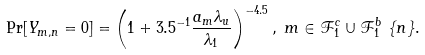<formula> <loc_0><loc_0><loc_500><loc_500>& \Pr [ Y _ { m , n } = 0 ] = \left ( 1 + 3 . 5 ^ { - 1 } \frac { a _ { m } \lambda _ { u } } { \lambda _ { 1 } } \right ) ^ { - 4 . 5 } , \ m \in \mathcal { F } _ { 1 } ^ { c } \cup \mathcal { F } _ { 1 } ^ { b } \ \{ n \} .</formula> 